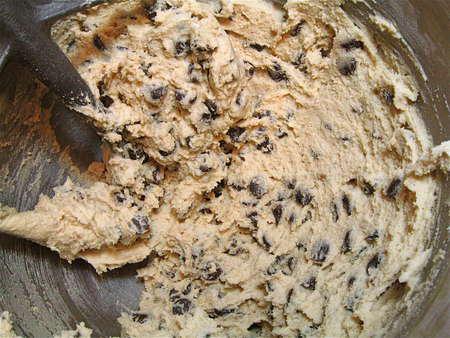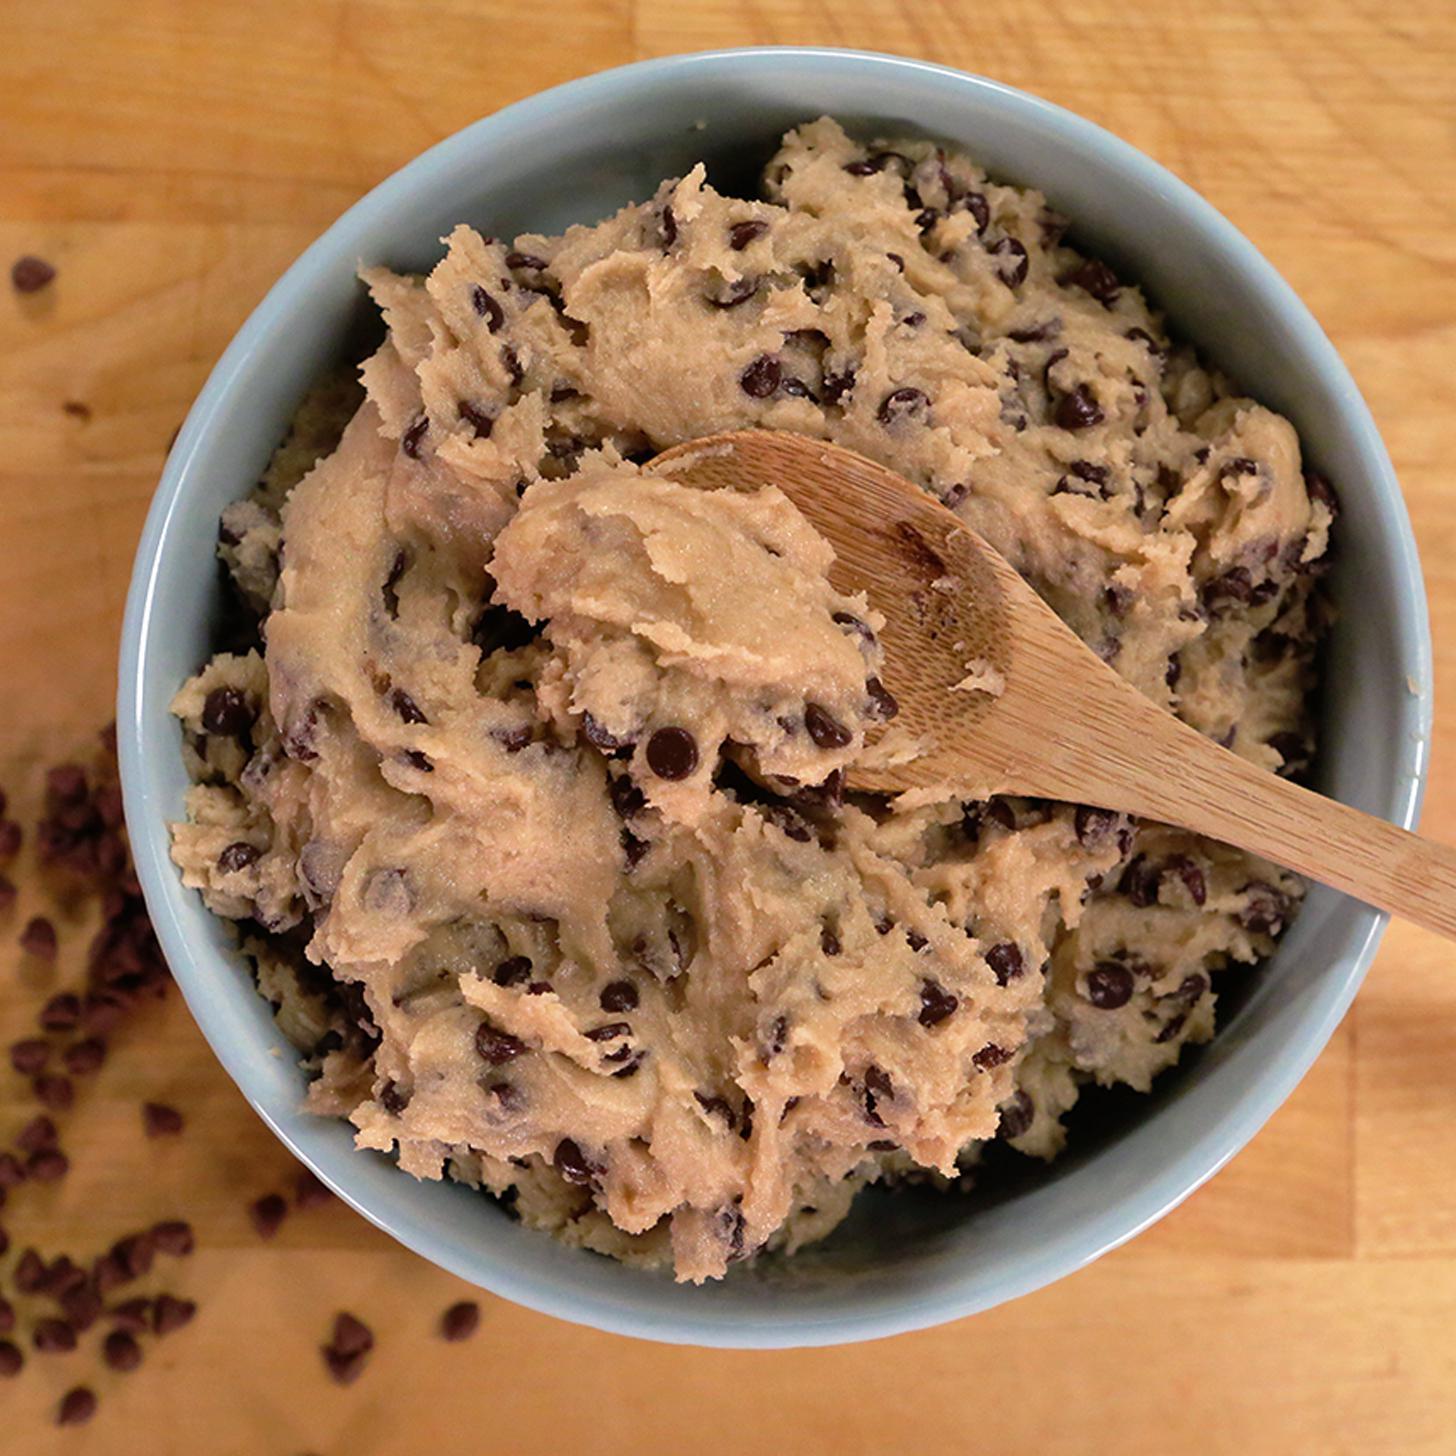The first image is the image on the left, the second image is the image on the right. Given the left and right images, does the statement "Each image shows cookie dough in a bowl with the handle of a utensil sticking out of it." hold true? Answer yes or no. Yes. The first image is the image on the left, the second image is the image on the right. Analyze the images presented: Is the assertion "A wooden spoon touching a dough is visible." valid? Answer yes or no. Yes. 